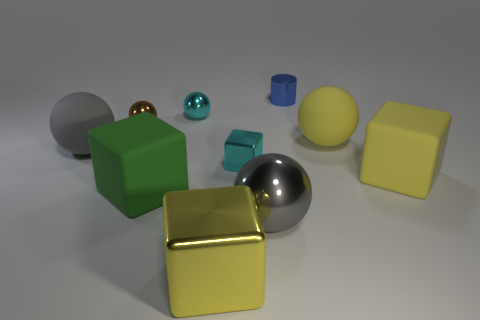What number of other things are there of the same color as the small cylinder?
Your answer should be compact. 0. There is a cylinder; are there any big gray shiny objects behind it?
Your answer should be very brief. No. What color is the big cube to the left of the big yellow block that is in front of the block right of the yellow matte ball?
Ensure brevity in your answer.  Green. What number of big rubber things are both on the left side of the cyan shiny block and in front of the small block?
Offer a very short reply. 1. How many cylinders are large green matte things or yellow matte things?
Ensure brevity in your answer.  0. Is there a red thing?
Ensure brevity in your answer.  No. How many other objects are there of the same material as the large yellow ball?
Provide a short and direct response. 3. What is the material of the gray thing that is the same size as the gray rubber ball?
Your answer should be very brief. Metal. Is the shape of the yellow object that is left of the metal cylinder the same as  the blue thing?
Your response must be concise. No. Do the tiny metal block and the big metallic block have the same color?
Your answer should be very brief. No. 